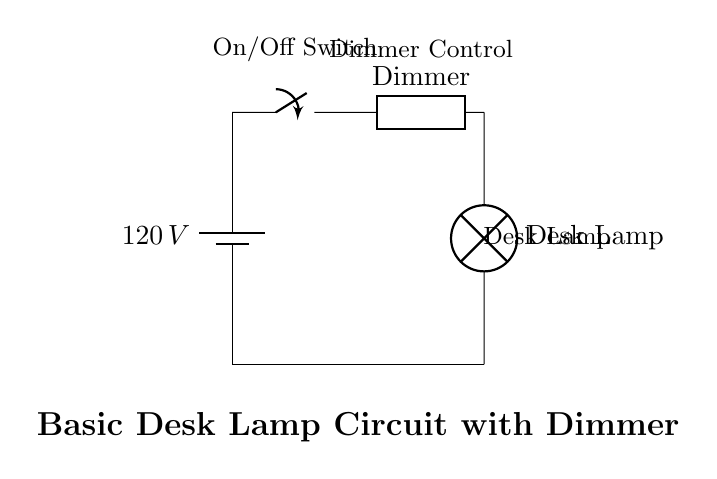What is the voltage of this circuit? The voltage is 120 volts, which is specified at the battery component in the circuit diagram.
Answer: 120 volts What is the function of the switch in this circuit? The switch serves to open or close the circuit, thus controlling whether the current flows to the lamp.
Answer: On/Off control How many components are in this circuit? There are four components: a battery, a switch, a dimmer, and a lamp.
Answer: Four What does the dimmer control adjust in this circuit? The dimmer control adjusts the brightness of the desk lamp by varying the amount of current that flows through it.
Answer: Brightness of the lamp Which component would you interact with to turn the lamp on? The switch is the component that you would interact with to turn the lamp on or off.
Answer: Switch What type of current flows in this circuit? The circuit operates with alternating current since it is a standard household voltage circuit.
Answer: Alternating current What happens to the circuit when the switch is open? When the switch is open, the circuit is incomplete, and no current flows to the lamp, meaning it will not illuminate.
Answer: No current flows 